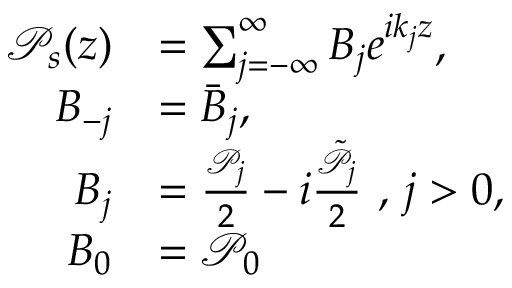Convert formula to latex. <formula><loc_0><loc_0><loc_500><loc_500>\begin{array} { r l } { \mathcal { P } _ { s } ( z ) } & { = \sum _ { j = - \infty } ^ { \infty } B _ { j } e ^ { i k _ { j } z } , } \\ { B _ { - j } } & { = \bar { B } _ { j } , } \\ { B _ { j } } & { = \frac { \mathcal { P } _ { j } } { 2 } - i \frac { \tilde { \mathcal { P } } _ { j } } { 2 } , j > 0 , } \\ { B _ { 0 } } & { = \mathcal { P } _ { 0 } } \end{array}</formula> 